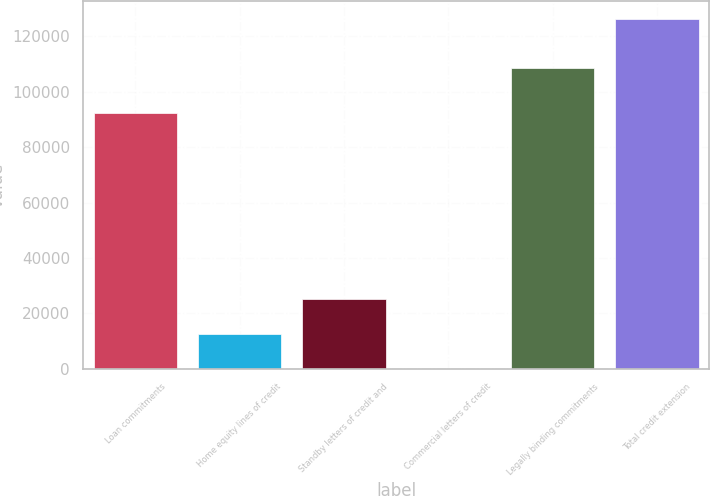<chart> <loc_0><loc_0><loc_500><loc_500><bar_chart><fcel>Loan commitments<fcel>Home equity lines of credit<fcel>Standby letters of credit and<fcel>Commercial letters of credit<fcel>Legally binding commitments<fcel>Total credit extension<nl><fcel>92153<fcel>12683.8<fcel>25317.6<fcel>50<fcel>108524<fcel>126388<nl></chart> 